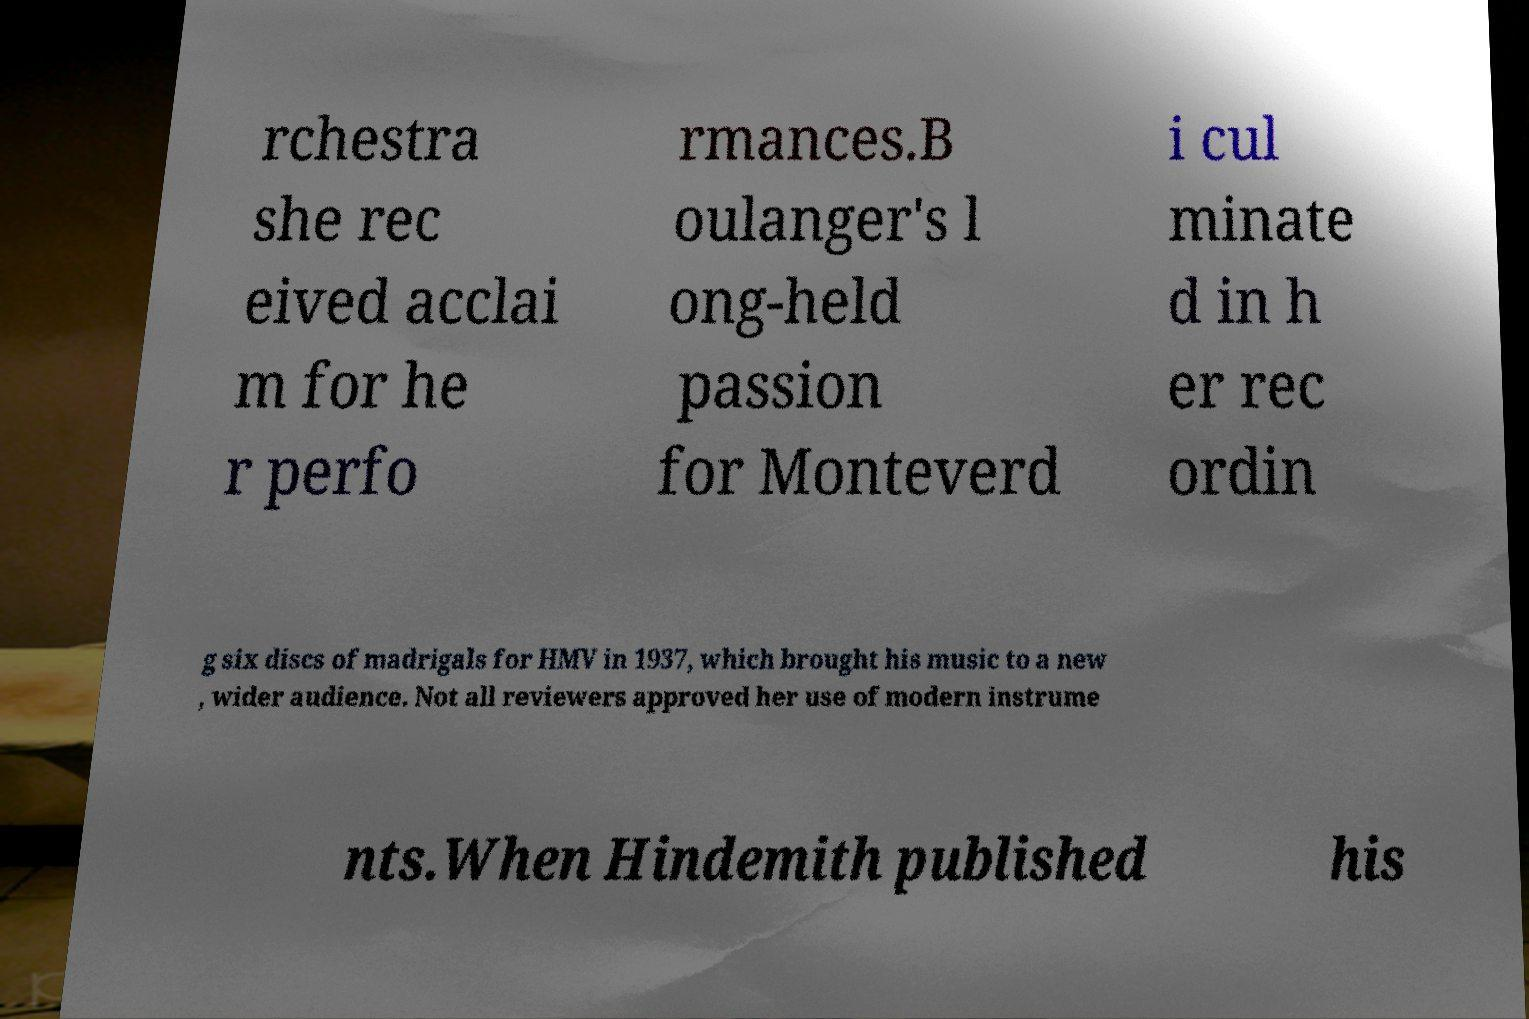Can you accurately transcribe the text from the provided image for me? rchestra she rec eived acclai m for he r perfo rmances.B oulanger's l ong-held passion for Monteverd i cul minate d in h er rec ordin g six discs of madrigals for HMV in 1937, which brought his music to a new , wider audience. Not all reviewers approved her use of modern instrume nts.When Hindemith published his 